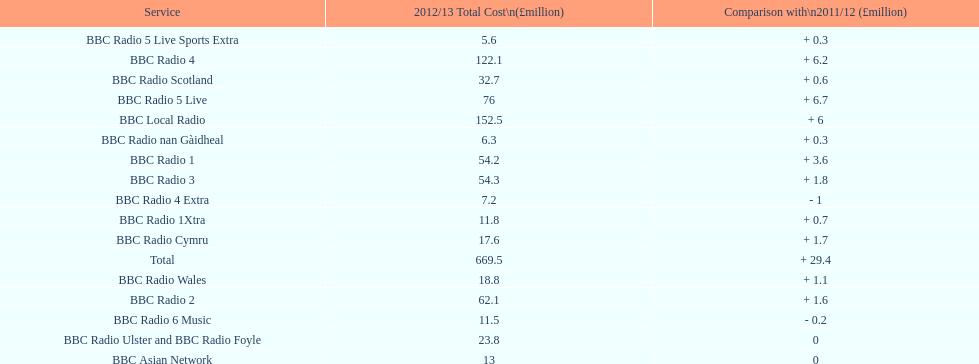Which bbc station had cost the most to run in 2012/13? BBC Local Radio. 